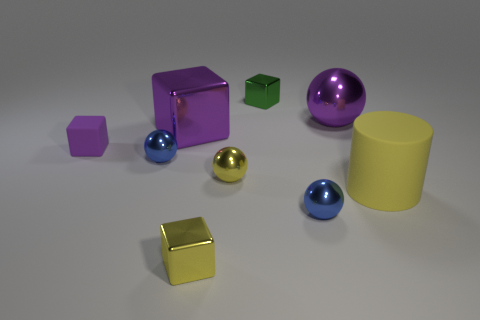Is the color of the large cylinder the same as the small metal block that is in front of the green cube?
Ensure brevity in your answer.  Yes. What is the size of the shiny cube that is both on the left side of the yellow metal ball and behind the large cylinder?
Give a very brief answer. Large. There is a small thing that is made of the same material as the cylinder; what is its shape?
Give a very brief answer. Cube. Are the tiny yellow block and the blue thing that is on the left side of the small yellow block made of the same material?
Provide a succinct answer. Yes. Are there any purple metallic things behind the small shiny ball on the left side of the yellow metal block?
Your response must be concise. Yes. There is a green thing that is the same shape as the small purple object; what material is it?
Give a very brief answer. Metal. There is a purple object on the right side of the small yellow sphere; what number of metal things are left of it?
Make the answer very short. 6. How many things are either tiny rubber cubes or big purple metallic cubes that are in front of the large shiny ball?
Offer a very short reply. 2. There is a sphere left of the purple shiny thing that is to the left of the tiny shiny block that is behind the small rubber thing; what is its material?
Keep it short and to the point. Metal. There is a purple cube that is made of the same material as the green block; what is its size?
Ensure brevity in your answer.  Large. 